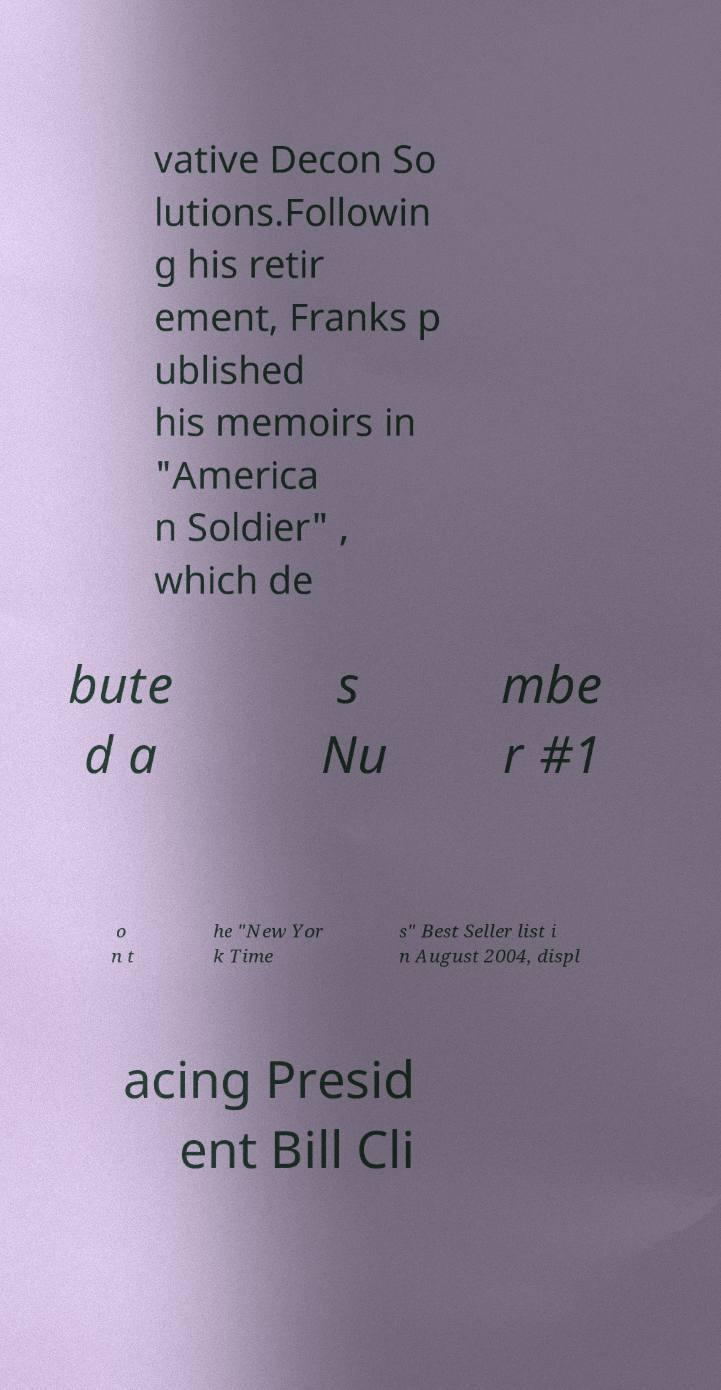What messages or text are displayed in this image? I need them in a readable, typed format. vative Decon So lutions.Followin g his retir ement, Franks p ublished his memoirs in "America n Soldier" , which de bute d a s Nu mbe r #1 o n t he "New Yor k Time s" Best Seller list i n August 2004, displ acing Presid ent Bill Cli 